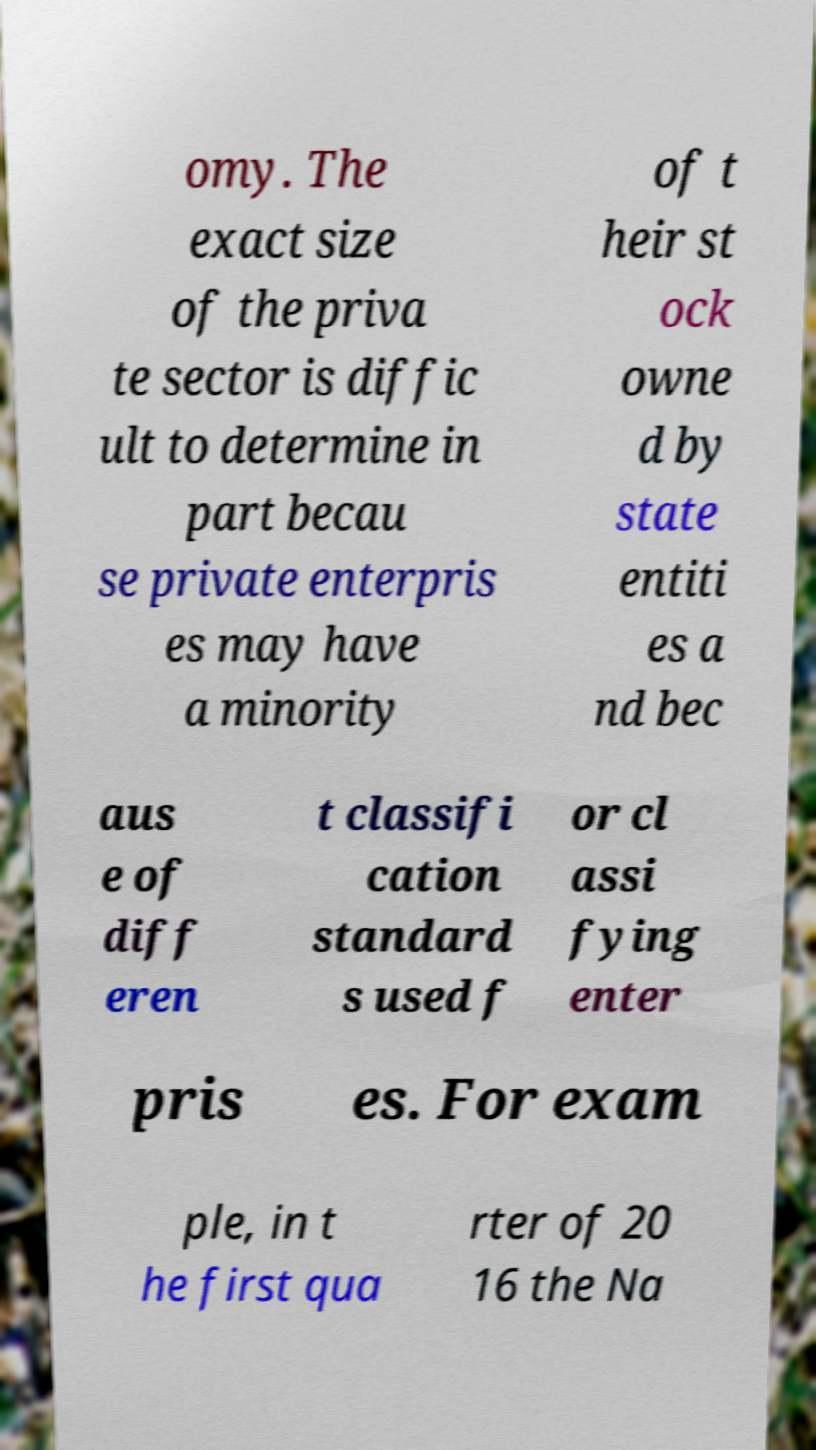Please identify and transcribe the text found in this image. omy. The exact size of the priva te sector is diffic ult to determine in part becau se private enterpris es may have a minority of t heir st ock owne d by state entiti es a nd bec aus e of diff eren t classifi cation standard s used f or cl assi fying enter pris es. For exam ple, in t he first qua rter of 20 16 the Na 